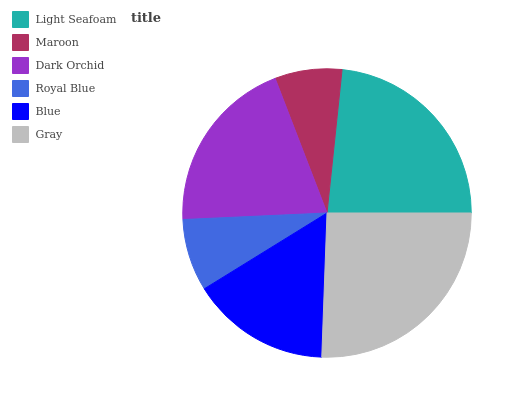Is Maroon the minimum?
Answer yes or no. Yes. Is Gray the maximum?
Answer yes or no. Yes. Is Dark Orchid the minimum?
Answer yes or no. No. Is Dark Orchid the maximum?
Answer yes or no. No. Is Dark Orchid greater than Maroon?
Answer yes or no. Yes. Is Maroon less than Dark Orchid?
Answer yes or no. Yes. Is Maroon greater than Dark Orchid?
Answer yes or no. No. Is Dark Orchid less than Maroon?
Answer yes or no. No. Is Dark Orchid the high median?
Answer yes or no. Yes. Is Blue the low median?
Answer yes or no. Yes. Is Royal Blue the high median?
Answer yes or no. No. Is Dark Orchid the low median?
Answer yes or no. No. 